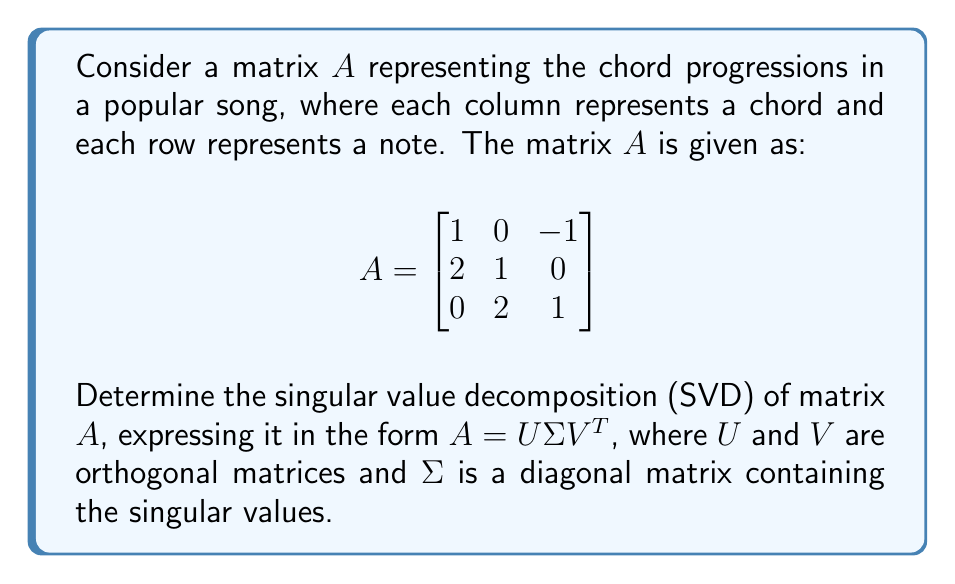What is the answer to this math problem? To find the singular value decomposition of matrix $A$, we'll follow these steps:

1) First, calculate $A^TA$:
   $$A^TA = \begin{bmatrix}
   1 & 2 & 0 \\
   0 & 1 & 2 \\
   -1 & 0 & 1
   \end{bmatrix} \begin{bmatrix}
   1 & 0 & -1 \\
   2 & 1 & 0 \\
   0 & 2 & 1
   \end{bmatrix} = \begin{bmatrix}
   5 & 2 & -1 \\
   2 & 5 & 2 \\
   -1 & 2 & 2
   \end{bmatrix}$$

2) Find the eigenvalues of $A^TA$ by solving the characteristic equation:
   $\det(A^TA - \lambda I) = 0$
   $\begin{vmatrix}
   5-\lambda & 2 & -1 \\
   2 & 5-\lambda & 2 \\
   -1 & 2 & 2-\lambda
   \end{vmatrix} = 0$
   
   Solving this equation gives us the eigenvalues: $\lambda_1 \approx 7.54$, $\lambda_2 \approx 3.41$, $\lambda_3 \approx 1.05$

3) The singular values are the square roots of these eigenvalues:
   $\sigma_1 \approx 2.75$, $\sigma_2 \approx 1.85$, $\sigma_3 \approx 1.02$

4) To find $V$, we need to find the eigenvectors of $A^TA$ corresponding to these eigenvalues. After normalization, we get:
   $$V \approx \begin{bmatrix}
   0.495 & -0.731 & 0.470 \\
   0.707 & 0.037 & -0.706 \\
   0.505 & 0.681 & 0.530
   \end{bmatrix}$$

5) To find $U$, we can use the relation $AV = U\Sigma$. Calculating $AV$ and dividing each column by the corresponding singular value gives us:
   $$U \approx \begin{bmatrix}
   0.192 & -0.815 & 0.547 \\
   0.764 & 0.166 & -0.623 \\
   0.616 & 0.555 & 0.559
   \end{bmatrix}$$

6) Finally, we can express $\Sigma$ as:
   $$\Sigma \approx \begin{bmatrix}
   2.75 & 0 & 0 \\
   0 & 1.85 & 0 \\
   0 & 0 & 1.02
   \end{bmatrix}$$

Thus, we have obtained the singular value decomposition $A = U\Sigma V^T$.
Answer: $A \approx \begin{bmatrix}
0.192 & -0.815 & 0.547 \\
0.764 & 0.166 & -0.623 \\
0.616 & 0.555 & 0.559
\end{bmatrix} \begin{bmatrix}
2.75 & 0 & 0 \\
0 & 1.85 & 0 \\
0 & 0 & 1.02
\end{bmatrix} \begin{bmatrix}
0.495 & 0.707 & 0.505 \\
-0.731 & 0.037 & 0.681 \\
0.470 & -0.706 & 0.530
\end{bmatrix}$ 